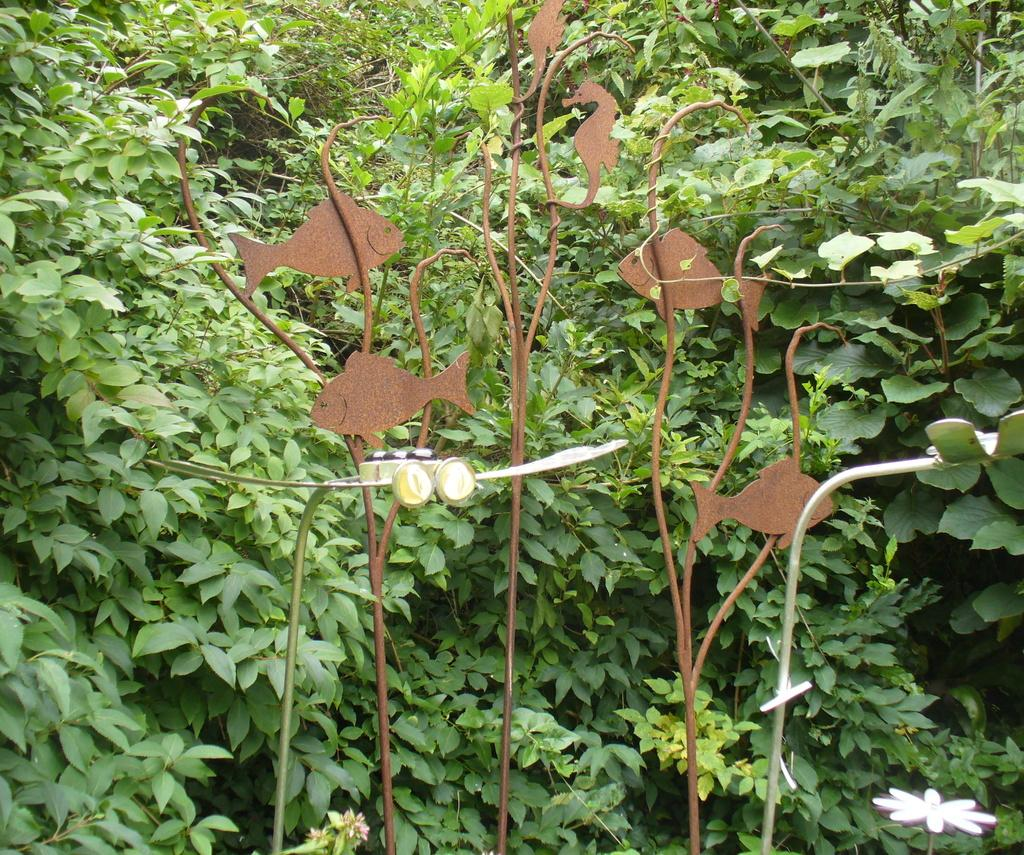What type of marine animals can be seen in the image? There are fishes and a seahorse in the image. What is the color of the object in the image? The object in the image is brown. Where is the white flower located in the image? The white flower is in the bottom right of the image. What can be seen in the background of the image? There are plants visible in the background of the image. How many dinosaurs can be seen in the image? There are no dinosaurs present in the image. What type of ghost is visible in the image? There is no ghost present in the image. 